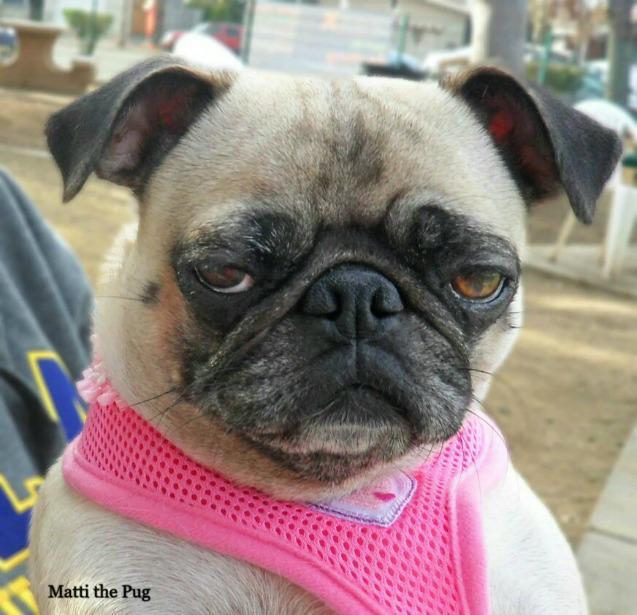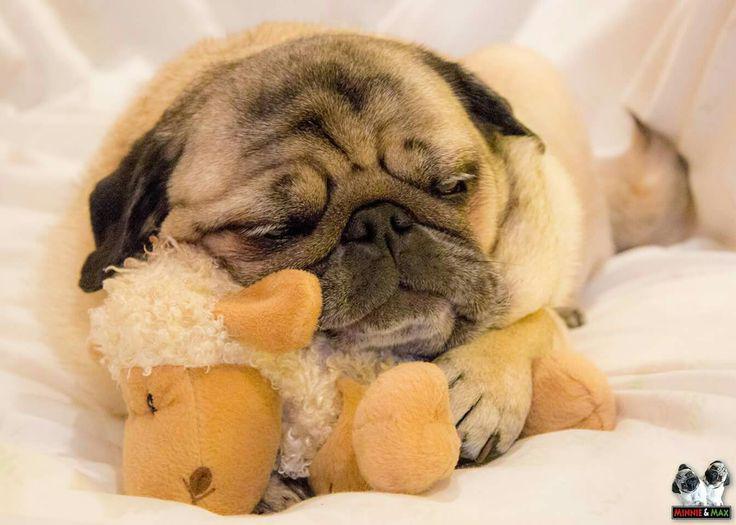The first image is the image on the left, the second image is the image on the right. Considering the images on both sides, is "The pug in the right image is posed with head and body facing forward, and with his front paws extended and farther apart than its body width." valid? Answer yes or no. No. 